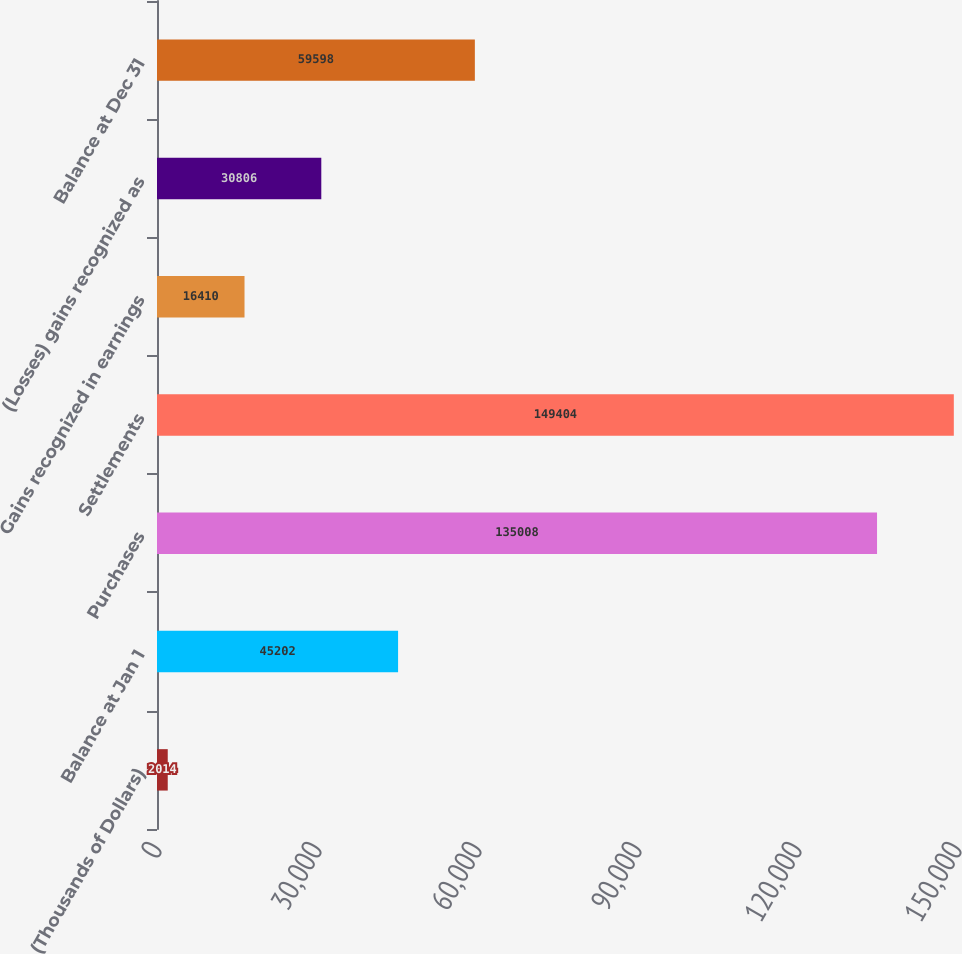<chart> <loc_0><loc_0><loc_500><loc_500><bar_chart><fcel>(Thousands of Dollars)<fcel>Balance at Jan 1<fcel>Purchases<fcel>Settlements<fcel>Gains recognized in earnings<fcel>(Losses) gains recognized as<fcel>Balance at Dec 31<nl><fcel>2014<fcel>45202<fcel>135008<fcel>149404<fcel>16410<fcel>30806<fcel>59598<nl></chart> 